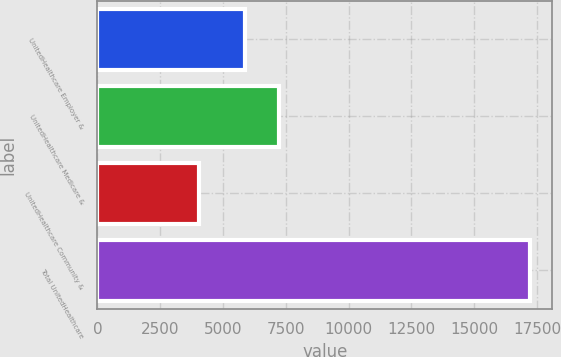Convert chart to OTSL. <chart><loc_0><loc_0><loc_500><loc_500><bar_chart><fcel>UnitedHealthcare Employer &<fcel>UnitedHealthcare Medicare &<fcel>UnitedHealthcare Community &<fcel>Total UnitedHealthcare<nl><fcel>5890<fcel>7210.4<fcel>4034<fcel>17238<nl></chart> 